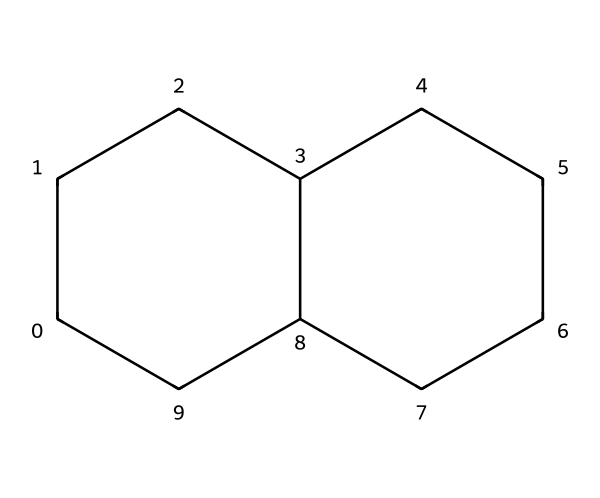What is the molecular formula of decalin? To obtain the molecular formula from the SMILES representation, identify the number of carbon (C) and hydrogen (H) atoms in the structure. The representation shows 10 carbon atoms, thus the molecular formula is C10. Each carbon will have enough hydrogen atoms to satisfy carbon's tetravalency, leading to 18 hydrogen atoms, resulting in C10H18.
Answer: C10H18 How many rings are present in decalin? By analyzing the structure indicated by the SMILES, it can be determined that there are two fused cyclohexane rings. Therefore, there are two rings in total.
Answer: 2 What type of cycloalkane is decalin? Decalin, with more than one ring structure, specifically consists of two cyclohexane units. This is characteristic of bicyclic compounds, which means decalin is a bicyclic cycloalkane.
Answer: bicyclic What is the degree of saturation of decalin? The degree of saturation can be calculated using the formula C - H/2 + N/2 + X/2 + 1, where C is the number of carbons, H is hydrogens, N is nitrogens, and X is halogens. For decalin, with 10 carbons and 18 hydrogens, the degree of saturation equals 10 - 18/2 + 1, yielding 5.
Answer: 5 Is decalin a saturated or unsaturated compound? Given that decalin has no double or triple bonds and contains only single bonds between all carbon atoms, it is classified as a saturated compound.
Answer: saturated 